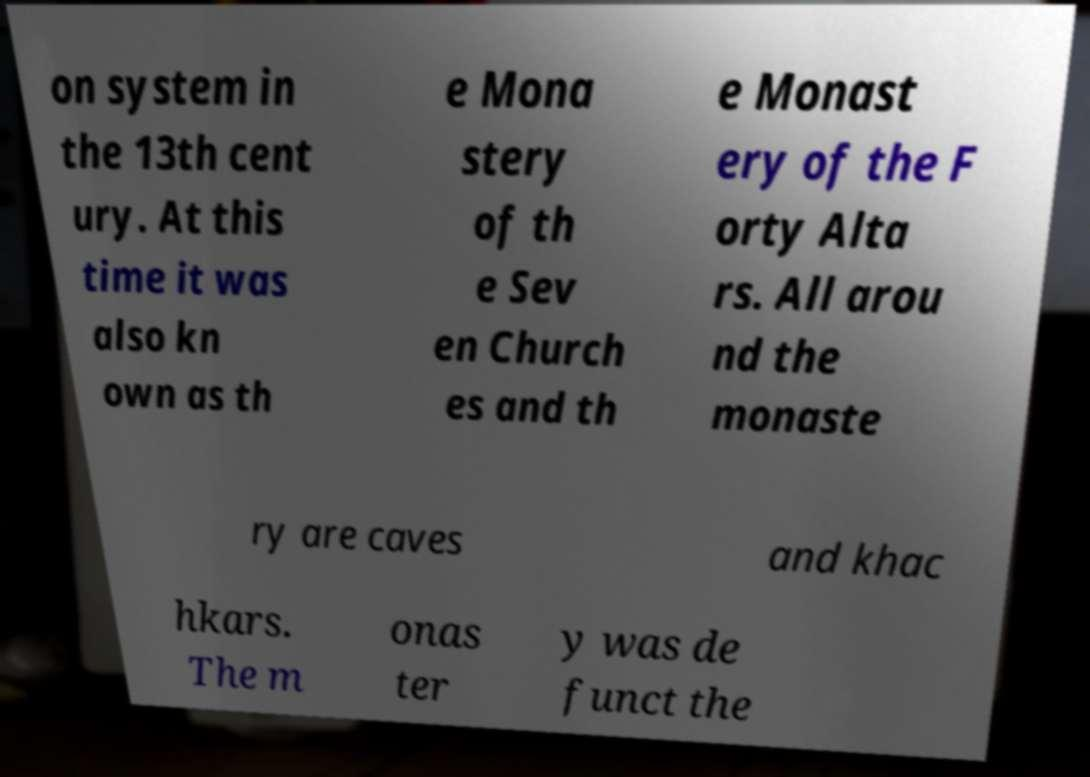There's text embedded in this image that I need extracted. Can you transcribe it verbatim? on system in the 13th cent ury. At this time it was also kn own as th e Mona stery of th e Sev en Church es and th e Monast ery of the F orty Alta rs. All arou nd the monaste ry are caves and khac hkars. The m onas ter y was de funct the 